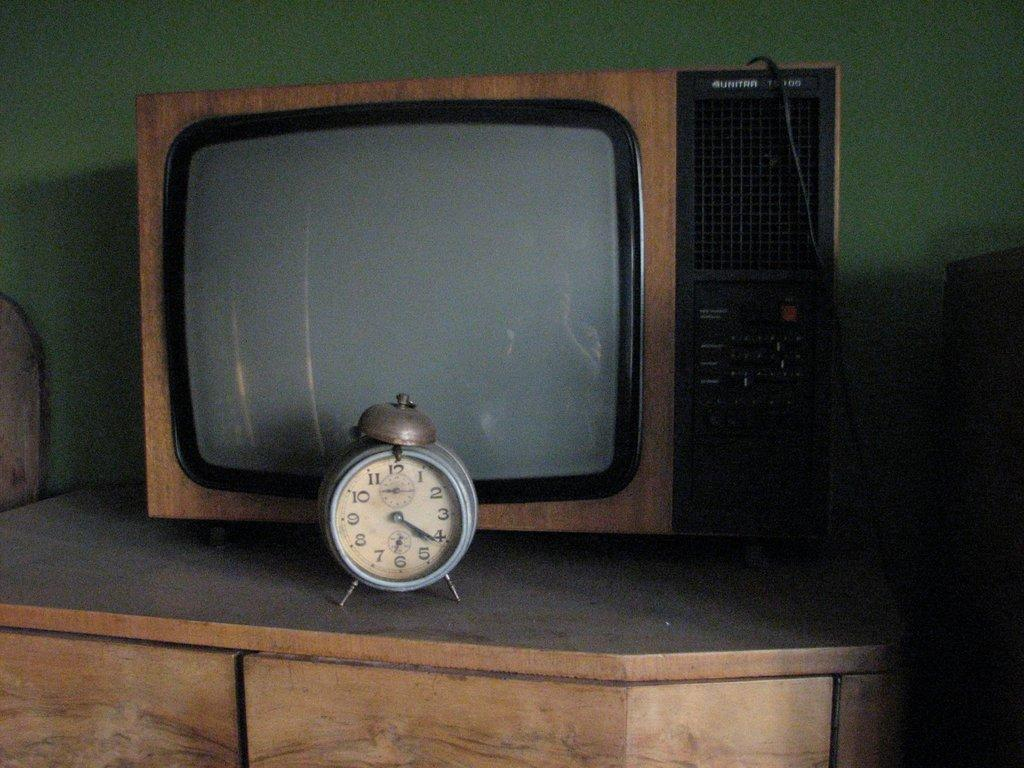Provide a one-sentence caption for the provided image. An alarm clock reading 4:21 sits in front of an old television. 